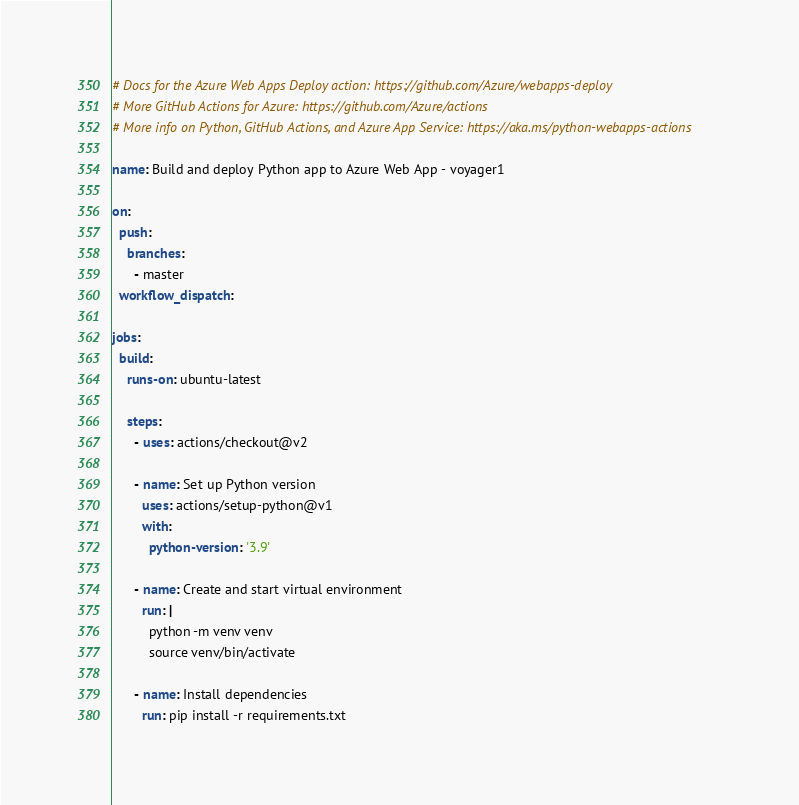<code> <loc_0><loc_0><loc_500><loc_500><_YAML_># Docs for the Azure Web Apps Deploy action: https://github.com/Azure/webapps-deploy
# More GitHub Actions for Azure: https://github.com/Azure/actions
# More info on Python, GitHub Actions, and Azure App Service: https://aka.ms/python-webapps-actions

name: Build and deploy Python app to Azure Web App - voyager1

on:
  push:
    branches:
      - master
  workflow_dispatch:

jobs:
  build:
    runs-on: ubuntu-latest

    steps:
      - uses: actions/checkout@v2

      - name: Set up Python version
        uses: actions/setup-python@v1
        with:
          python-version: '3.9'

      - name: Create and start virtual environment
        run: |
          python -m venv venv
          source venv/bin/activate
      
      - name: Install dependencies
        run: pip install -r requirements.txt</code> 